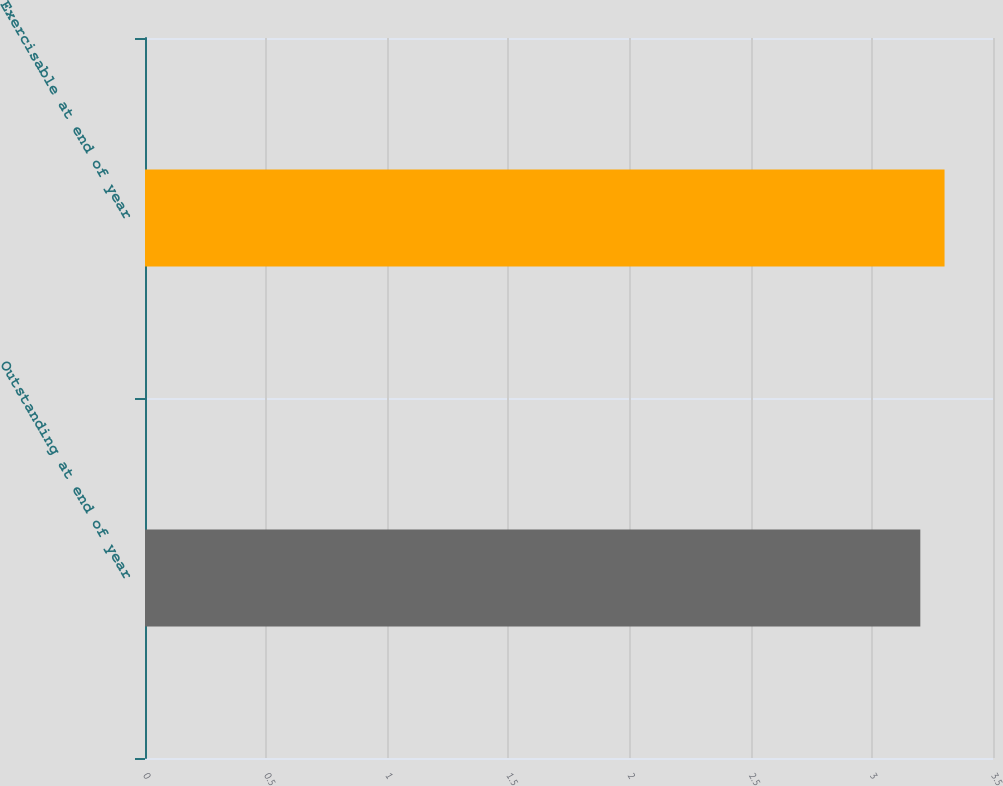<chart> <loc_0><loc_0><loc_500><loc_500><bar_chart><fcel>Outstanding at end of year<fcel>Exercisable at end of year<nl><fcel>3.2<fcel>3.3<nl></chart> 